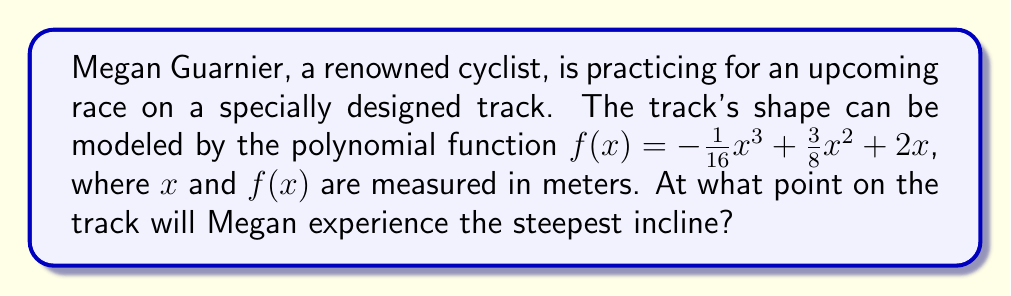Provide a solution to this math problem. To find the steepest incline on the track, we need to determine the point where the slope of the function is at its maximum. This can be done by following these steps:

1) First, we need to find the derivative of the function. This will give us the slope at any point:

   $f'(x) = -\frac{3}{16}x^2 + \frac{3}{4}x + 2$

2) To find the maximum slope, we need to find where the second derivative equals zero. Let's calculate the second derivative:

   $f''(x) = -\frac{3}{8}x + \frac{3}{4}$

3) Set the second derivative equal to zero and solve for x:

   $-\frac{3}{8}x + \frac{3}{4} = 0$
   $-\frac{3}{8}x = -\frac{3}{4}$
   $x = 2$

4) To confirm this is a maximum (steepest incline) and not a minimum, we can check the sign of the third derivative:

   $f'''(x) = -\frac{3}{8}$

   Since this is negative, we confirm that x = 2 gives us a maximum slope.

5) To find the y-coordinate of this point, we plug x = 2 into our original function:

   $f(2) = -\frac{1}{16}(2)^3 + \frac{3}{8}(2)^2 + 2(2)$
         $= -\frac{1}{2} + \frac{3}{2} + 4$
         $= 5$

Therefore, the point of steepest incline is at (2, 5) meters.
Answer: The steepest incline occurs at the point (2, 5) meters on the track. 